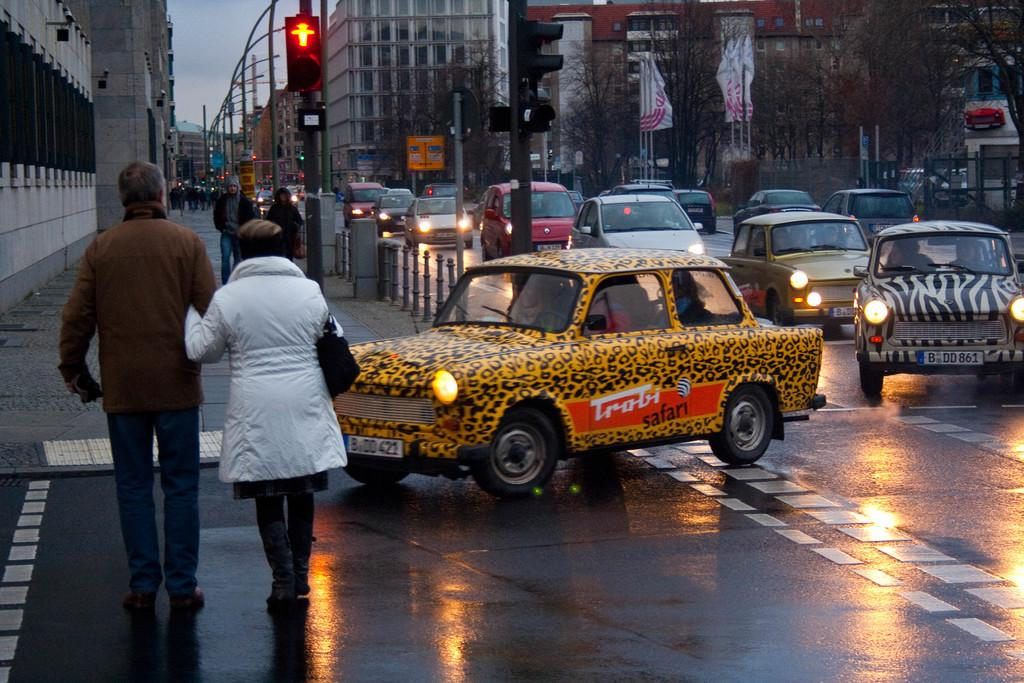<image>
Offer a succinct explanation of the picture presented. A leopard-print car says Trobi safari on the side. 